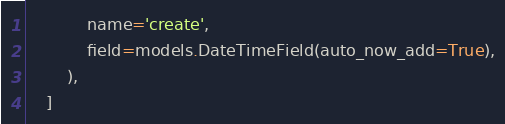Convert code to text. <code><loc_0><loc_0><loc_500><loc_500><_Python_>            name='create',
            field=models.DateTimeField(auto_now_add=True),
        ),
    ]
</code> 